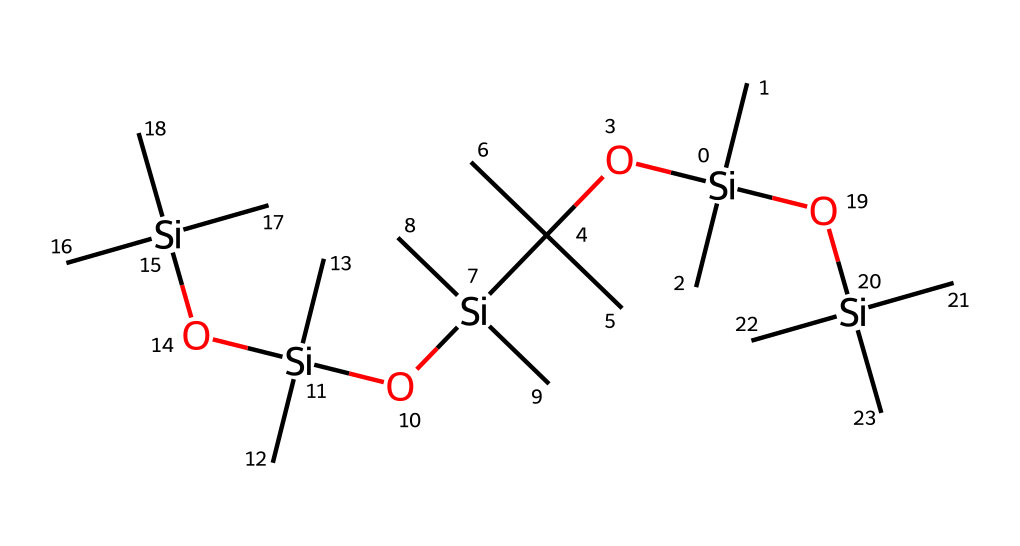What is the main element in this chemical? The main element shown in the SMILES representation is silicon, indicated by the presence of "Si" throughout the structure.
Answer: silicon How many carbon atoms are in this structure? By counting the "C" occurrences in the SMILES, there are a total of 18 carbon atoms present in the chemical structure.
Answer: 18 What type of chemical bond primarily connects the silicon atoms? The primary bonds connecting the silicon atoms in the structure are silicon-oxygen bonds, indicated by occurrences of "O" between "Si" atoms.
Answer: silicon-oxygen bonds Which functional group is prominently featured in this molecule? The molecule prominently features alkoxy groups (-O-C), as shown by the presence of "OC" units in the SMILES, suggesting connections to carbon chains.
Answer: alkoxy groups What is the overall structure type of this silane? The overall structure contains multiple branched silanes, indicated by the plethora of branching patterns emanating from the central silicon atoms in the SMILES.
Answer: branched silane How many silicon atoms are present in the structure? By counting the "Si" occurrences in the SMILES representation, there are a total of 5 silicon atoms in the chemical.
Answer: 5 What type of silane is this compound classified as? This compound can be classified as a silanol due to the presence of hydroxyl groups (–OH) implied by the "O" connections to silicon atoms in the structure.
Answer: silanol 